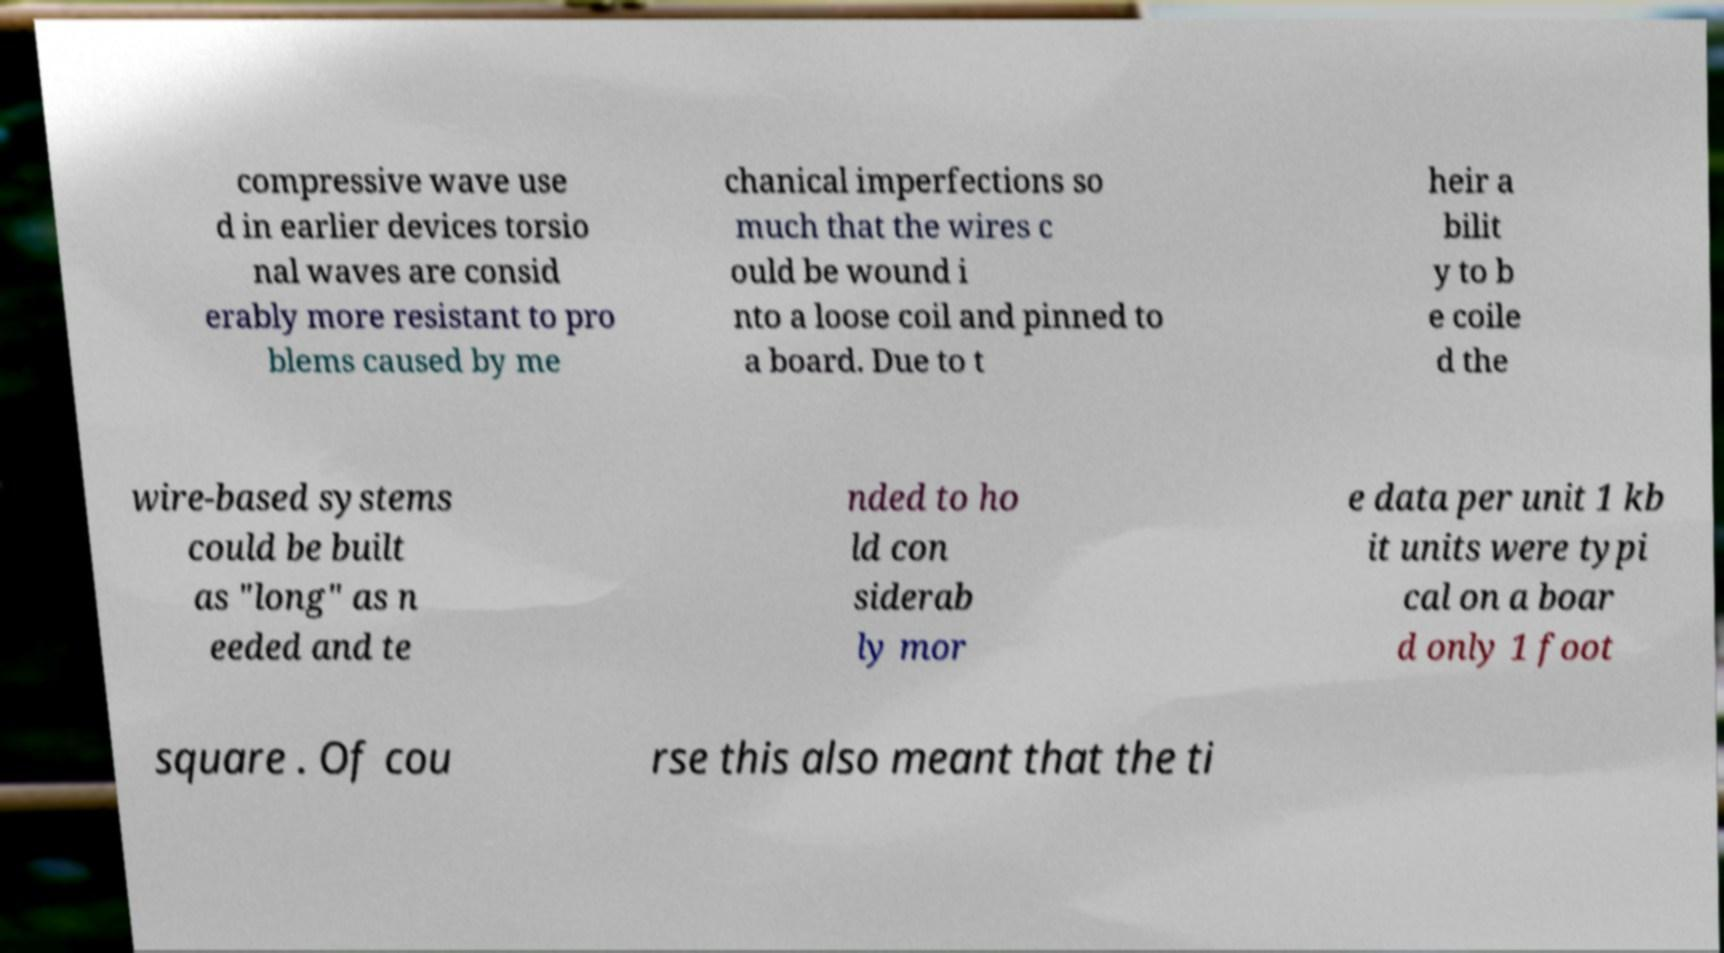What messages or text are displayed in this image? I need them in a readable, typed format. compressive wave use d in earlier devices torsio nal waves are consid erably more resistant to pro blems caused by me chanical imperfections so much that the wires c ould be wound i nto a loose coil and pinned to a board. Due to t heir a bilit y to b e coile d the wire-based systems could be built as "long" as n eeded and te nded to ho ld con siderab ly mor e data per unit 1 kb it units were typi cal on a boar d only 1 foot square . Of cou rse this also meant that the ti 